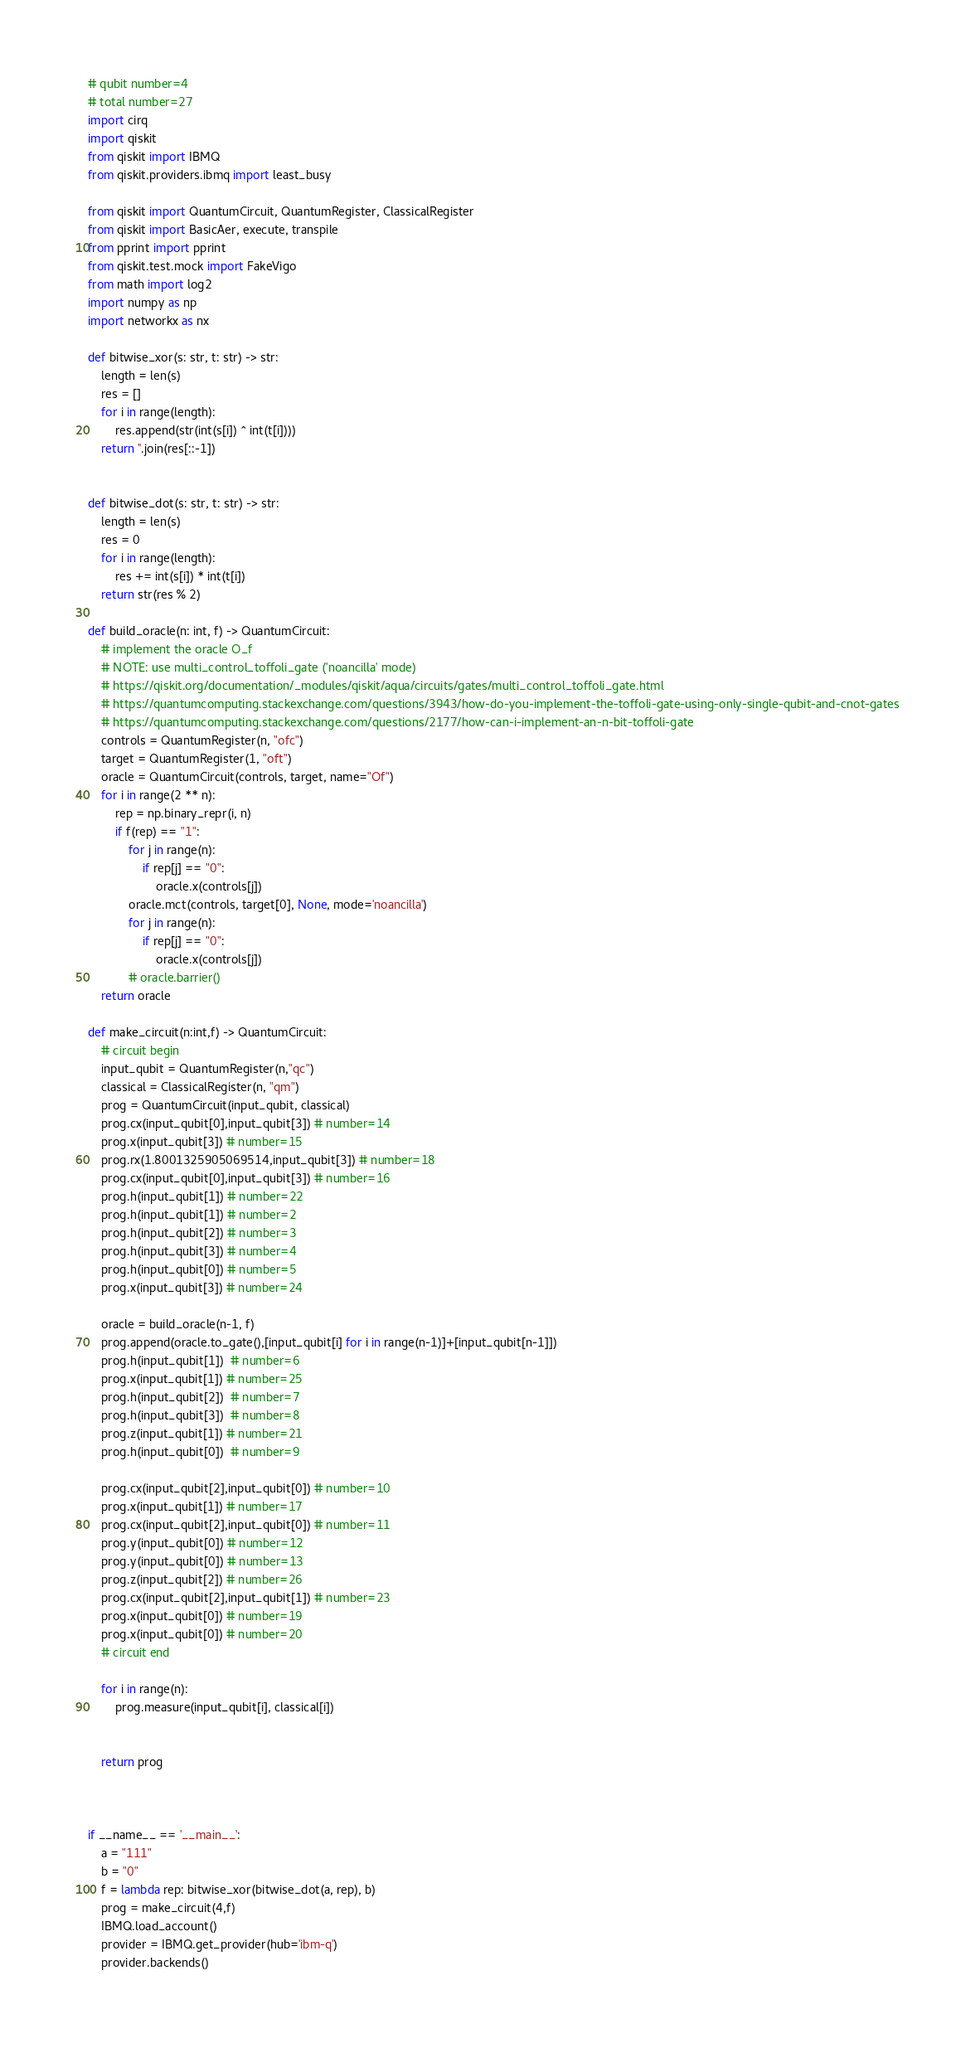<code> <loc_0><loc_0><loc_500><loc_500><_Python_># qubit number=4
# total number=27
import cirq
import qiskit
from qiskit import IBMQ
from qiskit.providers.ibmq import least_busy

from qiskit import QuantumCircuit, QuantumRegister, ClassicalRegister
from qiskit import BasicAer, execute, transpile
from pprint import pprint
from qiskit.test.mock import FakeVigo
from math import log2
import numpy as np
import networkx as nx

def bitwise_xor(s: str, t: str) -> str:
    length = len(s)
    res = []
    for i in range(length):
        res.append(str(int(s[i]) ^ int(t[i])))
    return ''.join(res[::-1])


def bitwise_dot(s: str, t: str) -> str:
    length = len(s)
    res = 0
    for i in range(length):
        res += int(s[i]) * int(t[i])
    return str(res % 2)

def build_oracle(n: int, f) -> QuantumCircuit:
    # implement the oracle O_f
    # NOTE: use multi_control_toffoli_gate ('noancilla' mode)
    # https://qiskit.org/documentation/_modules/qiskit/aqua/circuits/gates/multi_control_toffoli_gate.html
    # https://quantumcomputing.stackexchange.com/questions/3943/how-do-you-implement-the-toffoli-gate-using-only-single-qubit-and-cnot-gates
    # https://quantumcomputing.stackexchange.com/questions/2177/how-can-i-implement-an-n-bit-toffoli-gate
    controls = QuantumRegister(n, "ofc")
    target = QuantumRegister(1, "oft")
    oracle = QuantumCircuit(controls, target, name="Of")
    for i in range(2 ** n):
        rep = np.binary_repr(i, n)
        if f(rep) == "1":
            for j in range(n):
                if rep[j] == "0":
                    oracle.x(controls[j])
            oracle.mct(controls, target[0], None, mode='noancilla')
            for j in range(n):
                if rep[j] == "0":
                    oracle.x(controls[j])
            # oracle.barrier()
    return oracle

def make_circuit(n:int,f) -> QuantumCircuit:
    # circuit begin
    input_qubit = QuantumRegister(n,"qc")
    classical = ClassicalRegister(n, "qm")
    prog = QuantumCircuit(input_qubit, classical)
    prog.cx(input_qubit[0],input_qubit[3]) # number=14
    prog.x(input_qubit[3]) # number=15
    prog.rx(1.8001325905069514,input_qubit[3]) # number=18
    prog.cx(input_qubit[0],input_qubit[3]) # number=16
    prog.h(input_qubit[1]) # number=22
    prog.h(input_qubit[1]) # number=2
    prog.h(input_qubit[2]) # number=3
    prog.h(input_qubit[3]) # number=4
    prog.h(input_qubit[0]) # number=5
    prog.x(input_qubit[3]) # number=24

    oracle = build_oracle(n-1, f)
    prog.append(oracle.to_gate(),[input_qubit[i] for i in range(n-1)]+[input_qubit[n-1]])
    prog.h(input_qubit[1])  # number=6
    prog.x(input_qubit[1]) # number=25
    prog.h(input_qubit[2])  # number=7
    prog.h(input_qubit[3])  # number=8
    prog.z(input_qubit[1]) # number=21
    prog.h(input_qubit[0])  # number=9

    prog.cx(input_qubit[2],input_qubit[0]) # number=10
    prog.x(input_qubit[1]) # number=17
    prog.cx(input_qubit[2],input_qubit[0]) # number=11
    prog.y(input_qubit[0]) # number=12
    prog.y(input_qubit[0]) # number=13
    prog.z(input_qubit[2]) # number=26
    prog.cx(input_qubit[2],input_qubit[1]) # number=23
    prog.x(input_qubit[0]) # number=19
    prog.x(input_qubit[0]) # number=20
    # circuit end

    for i in range(n):
        prog.measure(input_qubit[i], classical[i])


    return prog



if __name__ == '__main__':
    a = "111"
    b = "0"
    f = lambda rep: bitwise_xor(bitwise_dot(a, rep), b)
    prog = make_circuit(4,f)
    IBMQ.load_account() 
    provider = IBMQ.get_provider(hub='ibm-q') 
    provider.backends()</code> 